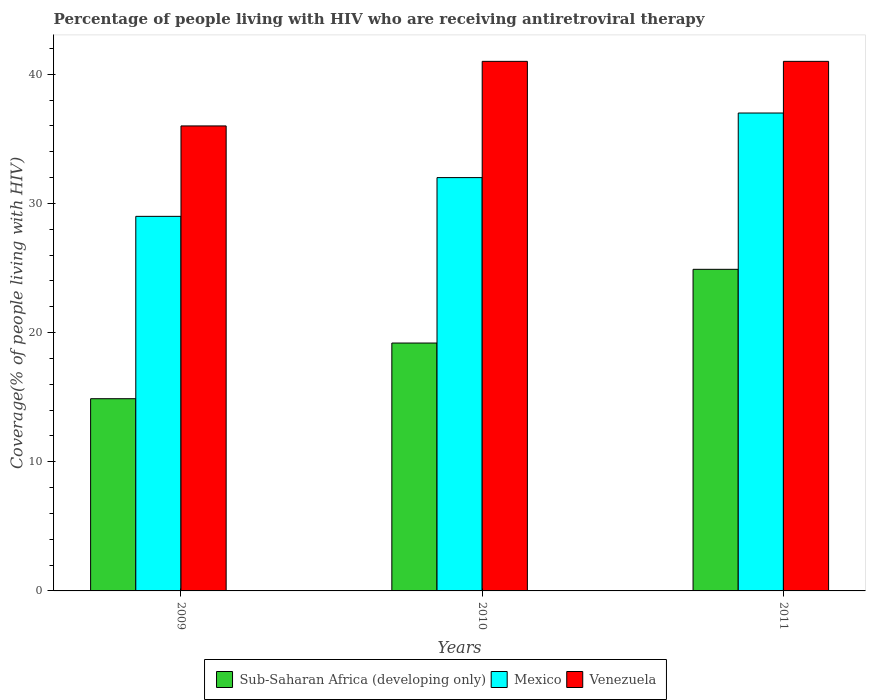How many groups of bars are there?
Your answer should be compact. 3. Are the number of bars per tick equal to the number of legend labels?
Your answer should be very brief. Yes. Are the number of bars on each tick of the X-axis equal?
Ensure brevity in your answer.  Yes. How many bars are there on the 3rd tick from the left?
Give a very brief answer. 3. What is the label of the 1st group of bars from the left?
Offer a terse response. 2009. In how many cases, is the number of bars for a given year not equal to the number of legend labels?
Your answer should be compact. 0. What is the percentage of the HIV infected people who are receiving antiretroviral therapy in Mexico in 2011?
Make the answer very short. 37. Across all years, what is the maximum percentage of the HIV infected people who are receiving antiretroviral therapy in Venezuela?
Offer a very short reply. 41. Across all years, what is the minimum percentage of the HIV infected people who are receiving antiretroviral therapy in Venezuela?
Your answer should be compact. 36. In which year was the percentage of the HIV infected people who are receiving antiretroviral therapy in Sub-Saharan Africa (developing only) maximum?
Provide a short and direct response. 2011. What is the total percentage of the HIV infected people who are receiving antiretroviral therapy in Mexico in the graph?
Offer a very short reply. 98. What is the difference between the percentage of the HIV infected people who are receiving antiretroviral therapy in Mexico in 2010 and that in 2011?
Your answer should be compact. -5. What is the difference between the percentage of the HIV infected people who are receiving antiretroviral therapy in Sub-Saharan Africa (developing only) in 2010 and the percentage of the HIV infected people who are receiving antiretroviral therapy in Venezuela in 2009?
Your answer should be compact. -16.81. What is the average percentage of the HIV infected people who are receiving antiretroviral therapy in Venezuela per year?
Your answer should be very brief. 39.33. In the year 2011, what is the difference between the percentage of the HIV infected people who are receiving antiretroviral therapy in Venezuela and percentage of the HIV infected people who are receiving antiretroviral therapy in Mexico?
Give a very brief answer. 4. What is the ratio of the percentage of the HIV infected people who are receiving antiretroviral therapy in Sub-Saharan Africa (developing only) in 2009 to that in 2010?
Make the answer very short. 0.78. Is the difference between the percentage of the HIV infected people who are receiving antiretroviral therapy in Venezuela in 2009 and 2011 greater than the difference between the percentage of the HIV infected people who are receiving antiretroviral therapy in Mexico in 2009 and 2011?
Give a very brief answer. Yes. What is the difference between the highest and the lowest percentage of the HIV infected people who are receiving antiretroviral therapy in Sub-Saharan Africa (developing only)?
Offer a terse response. 10.02. In how many years, is the percentage of the HIV infected people who are receiving antiretroviral therapy in Venezuela greater than the average percentage of the HIV infected people who are receiving antiretroviral therapy in Venezuela taken over all years?
Make the answer very short. 2. Is the sum of the percentage of the HIV infected people who are receiving antiretroviral therapy in Mexico in 2009 and 2011 greater than the maximum percentage of the HIV infected people who are receiving antiretroviral therapy in Sub-Saharan Africa (developing only) across all years?
Provide a succinct answer. Yes. What does the 3rd bar from the left in 2009 represents?
Your answer should be compact. Venezuela. What does the 3rd bar from the right in 2011 represents?
Offer a terse response. Sub-Saharan Africa (developing only). How many bars are there?
Make the answer very short. 9. Are the values on the major ticks of Y-axis written in scientific E-notation?
Your answer should be compact. No. Does the graph contain any zero values?
Keep it short and to the point. No. Where does the legend appear in the graph?
Make the answer very short. Bottom center. How are the legend labels stacked?
Offer a very short reply. Horizontal. What is the title of the graph?
Offer a very short reply. Percentage of people living with HIV who are receiving antiretroviral therapy. What is the label or title of the Y-axis?
Ensure brevity in your answer.  Coverage(% of people living with HIV). What is the Coverage(% of people living with HIV) of Sub-Saharan Africa (developing only) in 2009?
Provide a short and direct response. 14.88. What is the Coverage(% of people living with HIV) in Sub-Saharan Africa (developing only) in 2010?
Your response must be concise. 19.19. What is the Coverage(% of people living with HIV) in Venezuela in 2010?
Provide a succinct answer. 41. What is the Coverage(% of people living with HIV) in Sub-Saharan Africa (developing only) in 2011?
Offer a very short reply. 24.9. What is the Coverage(% of people living with HIV) in Mexico in 2011?
Provide a short and direct response. 37. Across all years, what is the maximum Coverage(% of people living with HIV) of Sub-Saharan Africa (developing only)?
Your response must be concise. 24.9. Across all years, what is the maximum Coverage(% of people living with HIV) in Mexico?
Offer a terse response. 37. Across all years, what is the minimum Coverage(% of people living with HIV) of Sub-Saharan Africa (developing only)?
Give a very brief answer. 14.88. Across all years, what is the minimum Coverage(% of people living with HIV) in Mexico?
Offer a terse response. 29. Across all years, what is the minimum Coverage(% of people living with HIV) of Venezuela?
Keep it short and to the point. 36. What is the total Coverage(% of people living with HIV) of Sub-Saharan Africa (developing only) in the graph?
Give a very brief answer. 58.97. What is the total Coverage(% of people living with HIV) of Venezuela in the graph?
Offer a terse response. 118. What is the difference between the Coverage(% of people living with HIV) of Sub-Saharan Africa (developing only) in 2009 and that in 2010?
Offer a very short reply. -4.31. What is the difference between the Coverage(% of people living with HIV) in Sub-Saharan Africa (developing only) in 2009 and that in 2011?
Give a very brief answer. -10.02. What is the difference between the Coverage(% of people living with HIV) of Venezuela in 2009 and that in 2011?
Offer a terse response. -5. What is the difference between the Coverage(% of people living with HIV) in Sub-Saharan Africa (developing only) in 2010 and that in 2011?
Ensure brevity in your answer.  -5.71. What is the difference between the Coverage(% of people living with HIV) in Mexico in 2010 and that in 2011?
Your answer should be very brief. -5. What is the difference between the Coverage(% of people living with HIV) of Sub-Saharan Africa (developing only) in 2009 and the Coverage(% of people living with HIV) of Mexico in 2010?
Offer a very short reply. -17.12. What is the difference between the Coverage(% of people living with HIV) in Sub-Saharan Africa (developing only) in 2009 and the Coverage(% of people living with HIV) in Venezuela in 2010?
Make the answer very short. -26.12. What is the difference between the Coverage(% of people living with HIV) in Mexico in 2009 and the Coverage(% of people living with HIV) in Venezuela in 2010?
Provide a succinct answer. -12. What is the difference between the Coverage(% of people living with HIV) in Sub-Saharan Africa (developing only) in 2009 and the Coverage(% of people living with HIV) in Mexico in 2011?
Your response must be concise. -22.12. What is the difference between the Coverage(% of people living with HIV) of Sub-Saharan Africa (developing only) in 2009 and the Coverage(% of people living with HIV) of Venezuela in 2011?
Your response must be concise. -26.12. What is the difference between the Coverage(% of people living with HIV) of Sub-Saharan Africa (developing only) in 2010 and the Coverage(% of people living with HIV) of Mexico in 2011?
Your response must be concise. -17.81. What is the difference between the Coverage(% of people living with HIV) in Sub-Saharan Africa (developing only) in 2010 and the Coverage(% of people living with HIV) in Venezuela in 2011?
Ensure brevity in your answer.  -21.81. What is the difference between the Coverage(% of people living with HIV) of Mexico in 2010 and the Coverage(% of people living with HIV) of Venezuela in 2011?
Provide a succinct answer. -9. What is the average Coverage(% of people living with HIV) in Sub-Saharan Africa (developing only) per year?
Make the answer very short. 19.66. What is the average Coverage(% of people living with HIV) of Mexico per year?
Provide a short and direct response. 32.67. What is the average Coverage(% of people living with HIV) in Venezuela per year?
Your answer should be very brief. 39.33. In the year 2009, what is the difference between the Coverage(% of people living with HIV) of Sub-Saharan Africa (developing only) and Coverage(% of people living with HIV) of Mexico?
Your answer should be very brief. -14.12. In the year 2009, what is the difference between the Coverage(% of people living with HIV) of Sub-Saharan Africa (developing only) and Coverage(% of people living with HIV) of Venezuela?
Offer a very short reply. -21.12. In the year 2009, what is the difference between the Coverage(% of people living with HIV) of Mexico and Coverage(% of people living with HIV) of Venezuela?
Your answer should be compact. -7. In the year 2010, what is the difference between the Coverage(% of people living with HIV) of Sub-Saharan Africa (developing only) and Coverage(% of people living with HIV) of Mexico?
Ensure brevity in your answer.  -12.81. In the year 2010, what is the difference between the Coverage(% of people living with HIV) of Sub-Saharan Africa (developing only) and Coverage(% of people living with HIV) of Venezuela?
Your answer should be compact. -21.81. In the year 2011, what is the difference between the Coverage(% of people living with HIV) in Sub-Saharan Africa (developing only) and Coverage(% of people living with HIV) in Mexico?
Provide a short and direct response. -12.1. In the year 2011, what is the difference between the Coverage(% of people living with HIV) in Sub-Saharan Africa (developing only) and Coverage(% of people living with HIV) in Venezuela?
Your answer should be very brief. -16.1. What is the ratio of the Coverage(% of people living with HIV) of Sub-Saharan Africa (developing only) in 2009 to that in 2010?
Offer a very short reply. 0.78. What is the ratio of the Coverage(% of people living with HIV) in Mexico in 2009 to that in 2010?
Make the answer very short. 0.91. What is the ratio of the Coverage(% of people living with HIV) of Venezuela in 2009 to that in 2010?
Your answer should be compact. 0.88. What is the ratio of the Coverage(% of people living with HIV) in Sub-Saharan Africa (developing only) in 2009 to that in 2011?
Ensure brevity in your answer.  0.6. What is the ratio of the Coverage(% of people living with HIV) of Mexico in 2009 to that in 2011?
Offer a terse response. 0.78. What is the ratio of the Coverage(% of people living with HIV) in Venezuela in 2009 to that in 2011?
Ensure brevity in your answer.  0.88. What is the ratio of the Coverage(% of people living with HIV) of Sub-Saharan Africa (developing only) in 2010 to that in 2011?
Your answer should be compact. 0.77. What is the ratio of the Coverage(% of people living with HIV) in Mexico in 2010 to that in 2011?
Your answer should be very brief. 0.86. What is the difference between the highest and the second highest Coverage(% of people living with HIV) of Sub-Saharan Africa (developing only)?
Ensure brevity in your answer.  5.71. What is the difference between the highest and the second highest Coverage(% of people living with HIV) of Mexico?
Keep it short and to the point. 5. What is the difference between the highest and the second highest Coverage(% of people living with HIV) in Venezuela?
Keep it short and to the point. 0. What is the difference between the highest and the lowest Coverage(% of people living with HIV) of Sub-Saharan Africa (developing only)?
Give a very brief answer. 10.02. What is the difference between the highest and the lowest Coverage(% of people living with HIV) in Mexico?
Your answer should be compact. 8. What is the difference between the highest and the lowest Coverage(% of people living with HIV) of Venezuela?
Make the answer very short. 5. 